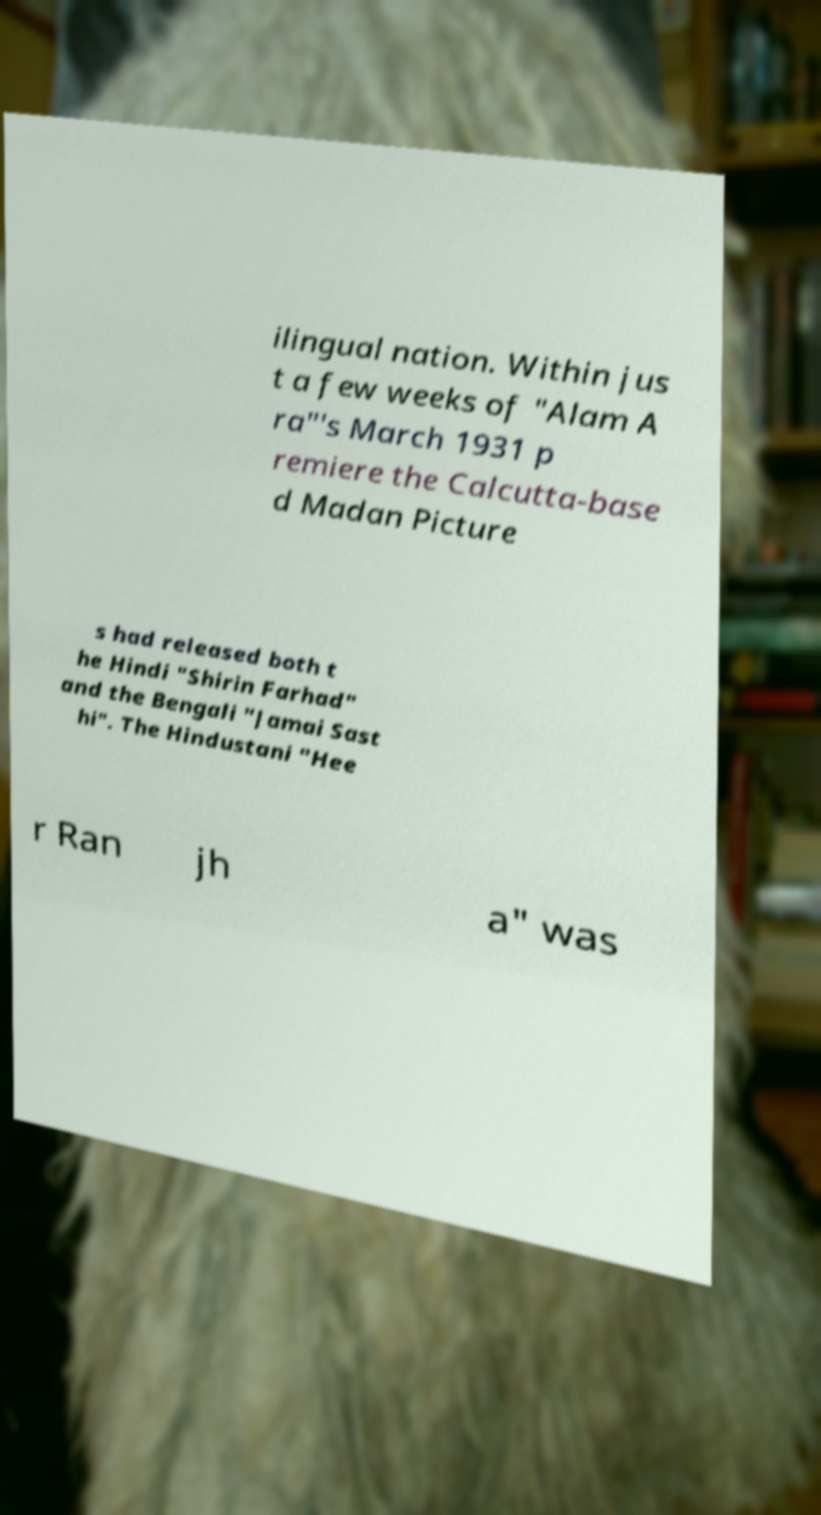There's text embedded in this image that I need extracted. Can you transcribe it verbatim? ilingual nation. Within jus t a few weeks of "Alam A ra"'s March 1931 p remiere the Calcutta-base d Madan Picture s had released both t he Hindi "Shirin Farhad" and the Bengali "Jamai Sast hi". The Hindustani "Hee r Ran jh a" was 